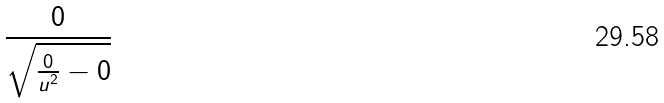Convert formula to latex. <formula><loc_0><loc_0><loc_500><loc_500>\frac { 0 } { \sqrt { \frac { 0 } { u ^ { 2 } } - 0 } }</formula> 